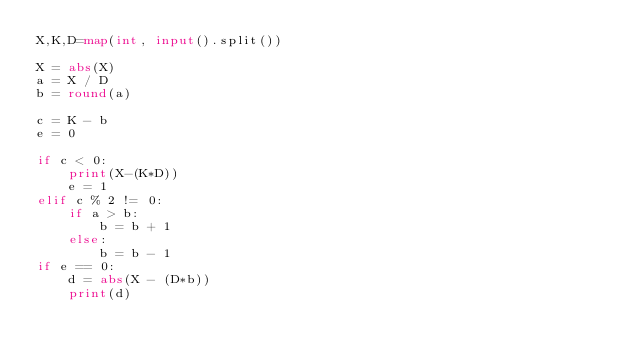Convert code to text. <code><loc_0><loc_0><loc_500><loc_500><_Python_>X,K,D=map(int, input().split())

X = abs(X)
a = X / D
b = round(a)

c = K - b
e = 0

if c < 0:
    print(X-(K*D))
    e = 1
elif c % 2 != 0:
    if a > b:
        b = b + 1
    else:
        b = b - 1
if e == 0:
    d = abs(X - (D*b))
    print(d)</code> 